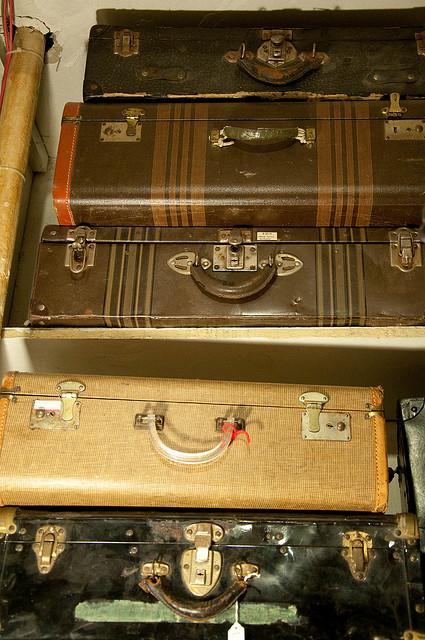Are the suitcases for sale?
Short answer required. Yes. How many suitcases have vertical stripes running down them?
Write a very short answer. 2. Are these new suitcases?
Short answer required. No. 